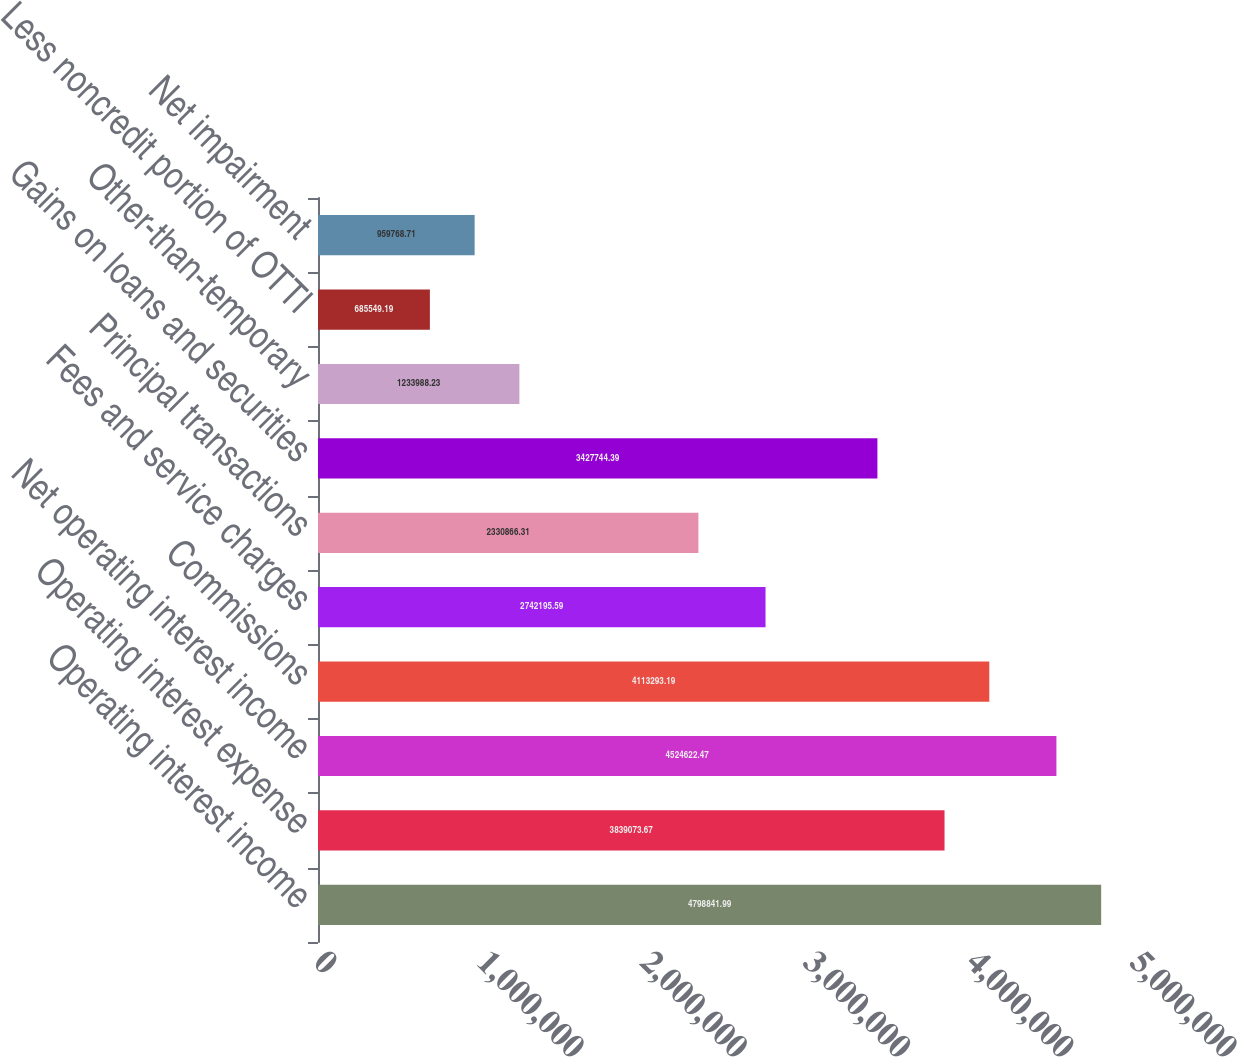Convert chart to OTSL. <chart><loc_0><loc_0><loc_500><loc_500><bar_chart><fcel>Operating interest income<fcel>Operating interest expense<fcel>Net operating interest income<fcel>Commissions<fcel>Fees and service charges<fcel>Principal transactions<fcel>Gains on loans and securities<fcel>Other-than-temporary<fcel>Less noncredit portion of OTTI<fcel>Net impairment<nl><fcel>4.79884e+06<fcel>3.83907e+06<fcel>4.52462e+06<fcel>4.11329e+06<fcel>2.7422e+06<fcel>2.33087e+06<fcel>3.42774e+06<fcel>1.23399e+06<fcel>685549<fcel>959769<nl></chart> 